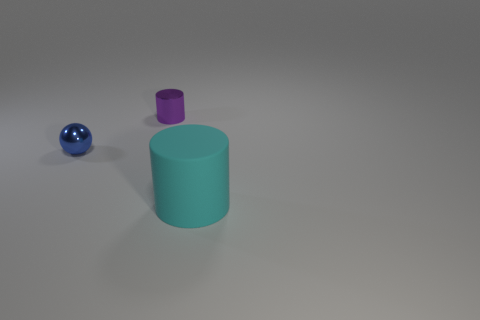Are there any other things that have the same material as the large cyan object?
Give a very brief answer. No. There is a thing in front of the metallic thing that is in front of the tiny object that is right of the small sphere; what size is it?
Offer a very short reply. Large. Are there any blue metallic balls behind the tiny blue metallic object?
Keep it short and to the point. No. What size is the cylinder that is made of the same material as the blue sphere?
Keep it short and to the point. Small. How many tiny cyan rubber objects have the same shape as the large object?
Your answer should be very brief. 0. Do the big cyan cylinder and the small thing that is left of the tiny cylinder have the same material?
Ensure brevity in your answer.  No. Is the number of purple cylinders right of the shiny cylinder greater than the number of blue metallic blocks?
Your answer should be compact. No. Are there any tiny blue balls that have the same material as the cyan thing?
Offer a very short reply. No. Are the object that is on the left side of the tiny metallic cylinder and the cylinder to the right of the tiny purple cylinder made of the same material?
Your answer should be compact. No. Are there the same number of tiny blue metallic spheres in front of the ball and big cyan things behind the purple thing?
Your answer should be compact. Yes. 